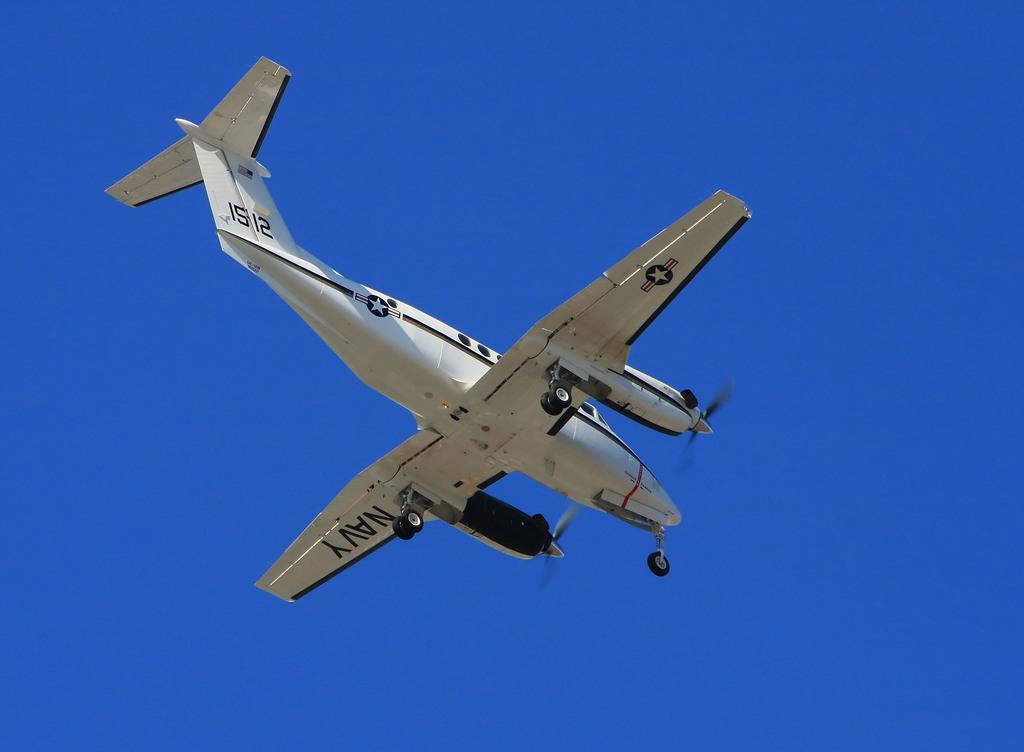Describe this image in one or two sentences. There is an aeroplane present in the middle of this image and the blue sky is in the background. 